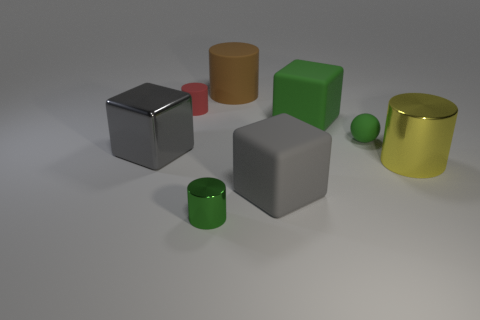Subtract all matte cubes. How many cubes are left? 1 Subtract all brown spheres. How many gray blocks are left? 2 Subtract all green cylinders. How many cylinders are left? 3 Add 1 red metal spheres. How many objects exist? 9 Subtract all yellow blocks. Subtract all red cylinders. How many blocks are left? 3 Subtract all cubes. How many objects are left? 5 Add 4 large green blocks. How many large green blocks are left? 5 Add 8 gray objects. How many gray objects exist? 10 Subtract 0 brown cubes. How many objects are left? 8 Subtract all big gray rubber things. Subtract all tiny red cylinders. How many objects are left? 6 